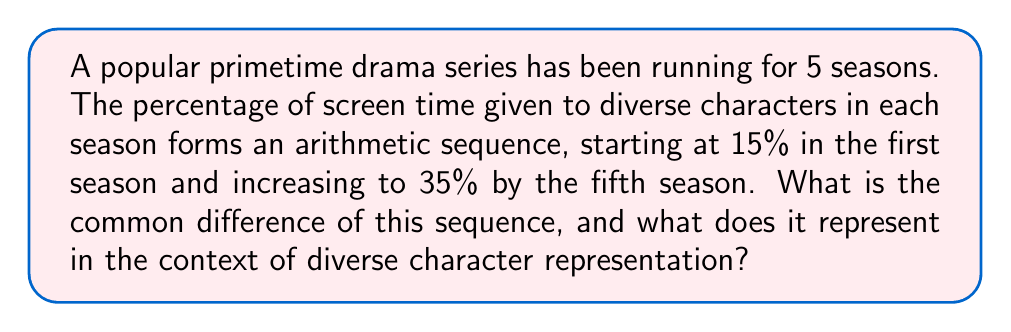Teach me how to tackle this problem. Let's approach this step-by-step:

1) In an arithmetic sequence, the difference between any two consecutive terms is constant. This is called the common difference.

2) We are given:
   - First term (a₁) = 15%
   - Fifth term (a₅) = 35%
   - Number of terms (n) = 5

3) The formula for the nth term of an arithmetic sequence is:
   $a_n = a_1 + (n-1)d$
   where d is the common difference.

4) Substituting our known values:
   $35 = 15 + (5-1)d$

5) Simplifying:
   $35 = 15 + 4d$

6) Subtracting 15 from both sides:
   $20 = 4d$

7) Dividing both sides by 4:
   $d = 5$

8) Therefore, the common difference is 5 percentage points.

9) In the context of diverse character representation, this means that in each subsequent season, the percentage of screen time given to diverse characters increased by 5 percentage points.
Answer: 5 percentage points per season 